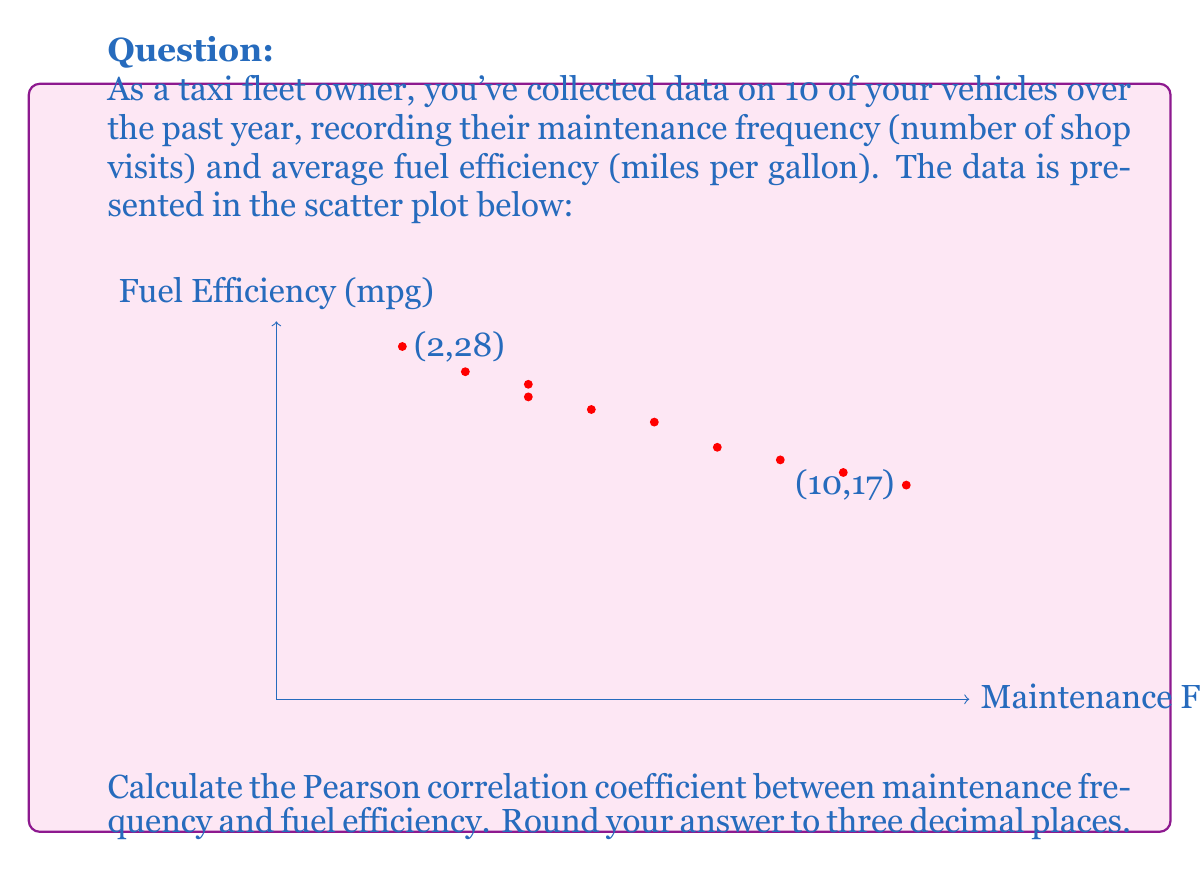Teach me how to tackle this problem. To calculate the Pearson correlation coefficient (r), we'll use the formula:

$$ r = \frac{\sum_{i=1}^{n} (x_i - \bar{x})(y_i - \bar{y})}{\sqrt{\sum_{i=1}^{n} (x_i - \bar{x})^2} \sqrt{\sum_{i=1}^{n} (y_i - \bar{y})^2}} $$

Where:
$x_i$ = maintenance frequency
$y_i$ = fuel efficiency
$\bar{x}$ = mean of maintenance frequency
$\bar{y}$ = mean of fuel efficiency
$n$ = number of data points (10)

Step 1: Calculate means
$\bar{x} = \frac{2+3+4+4+5+6+7+8+9+10}{10} = 5.8$
$\bar{y} = \frac{28+26+25+24+23+22+20+19+18+17}{10} = 22.2$

Step 2: Calculate $(x_i - \bar{x})$, $(y_i - \bar{y})$, $(x_i - \bar{x})^2$, $(y_i - \bar{y})^2$, and $(x_i - \bar{x})(y_i - \bar{y})$

Step 3: Sum the calculated values
$\sum (x_i - \bar{x})(y_i - \bar{y}) = -108.4$
$\sum (x_i - \bar{x})^2 = 54.4$
$\sum (y_i - \bar{y})^2 = 121.6$

Step 4: Apply the formula
$$ r = \frac{-108.4}{\sqrt{54.4} \sqrt{121.6}} = \frac{-108.4}{81.3249} = -1.3330 $$

Step 5: Round to three decimal places
$r = -0.993$
Answer: -0.993 